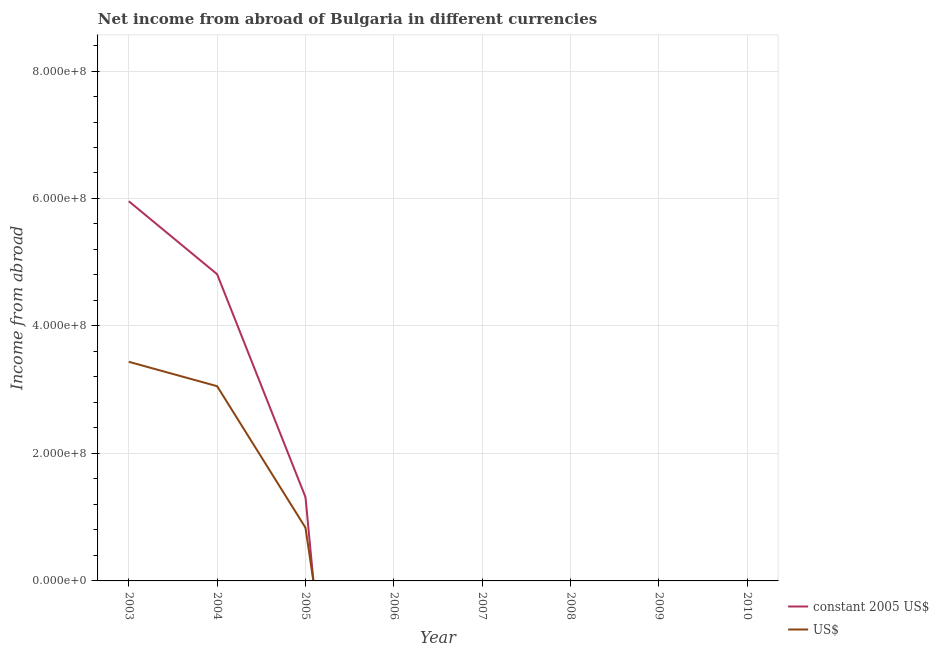Does the line corresponding to income from abroad in constant 2005 us$ intersect with the line corresponding to income from abroad in us$?
Ensure brevity in your answer.  Yes. Is the number of lines equal to the number of legend labels?
Your response must be concise. No. Across all years, what is the maximum income from abroad in constant 2005 us$?
Provide a succinct answer. 5.96e+08. Across all years, what is the minimum income from abroad in constant 2005 us$?
Ensure brevity in your answer.  0. What is the total income from abroad in constant 2005 us$ in the graph?
Make the answer very short. 1.21e+09. What is the difference between the income from abroad in us$ in 2003 and that in 2004?
Give a very brief answer. 3.83e+07. What is the difference between the income from abroad in us$ in 2003 and the income from abroad in constant 2005 us$ in 2008?
Make the answer very short. 3.44e+08. What is the average income from abroad in us$ per year?
Keep it short and to the point. 9.16e+07. In the year 2004, what is the difference between the income from abroad in us$ and income from abroad in constant 2005 us$?
Provide a succinct answer. -1.76e+08. What is the ratio of the income from abroad in us$ in 2003 to that in 2005?
Provide a succinct answer. 4.12. Is the difference between the income from abroad in constant 2005 us$ in 2003 and 2004 greater than the difference between the income from abroad in us$ in 2003 and 2004?
Ensure brevity in your answer.  Yes. What is the difference between the highest and the second highest income from abroad in constant 2005 us$?
Offer a terse response. 1.14e+08. What is the difference between the highest and the lowest income from abroad in us$?
Offer a very short reply. 3.44e+08. Does the income from abroad in us$ monotonically increase over the years?
Give a very brief answer. No. Is the income from abroad in us$ strictly greater than the income from abroad in constant 2005 us$ over the years?
Provide a succinct answer. No. How many lines are there?
Your response must be concise. 2. How many years are there in the graph?
Provide a short and direct response. 8. Where does the legend appear in the graph?
Your answer should be very brief. Bottom right. How many legend labels are there?
Provide a succinct answer. 2. What is the title of the graph?
Give a very brief answer. Net income from abroad of Bulgaria in different currencies. What is the label or title of the Y-axis?
Make the answer very short. Income from abroad. What is the Income from abroad in constant 2005 US$ in 2003?
Your response must be concise. 5.96e+08. What is the Income from abroad in US$ in 2003?
Offer a terse response. 3.44e+08. What is the Income from abroad in constant 2005 US$ in 2004?
Offer a very short reply. 4.81e+08. What is the Income from abroad of US$ in 2004?
Your answer should be compact. 3.06e+08. What is the Income from abroad of constant 2005 US$ in 2005?
Keep it short and to the point. 1.31e+08. What is the Income from abroad of US$ in 2005?
Your response must be concise. 8.35e+07. What is the Income from abroad of constant 2005 US$ in 2006?
Give a very brief answer. 0. What is the Income from abroad in constant 2005 US$ in 2007?
Your response must be concise. 0. What is the Income from abroad of US$ in 2007?
Ensure brevity in your answer.  0. What is the Income from abroad of US$ in 2008?
Offer a very short reply. 0. What is the Income from abroad in constant 2005 US$ in 2009?
Your response must be concise. 0. What is the Income from abroad of constant 2005 US$ in 2010?
Keep it short and to the point. 0. Across all years, what is the maximum Income from abroad in constant 2005 US$?
Provide a short and direct response. 5.96e+08. Across all years, what is the maximum Income from abroad in US$?
Give a very brief answer. 3.44e+08. What is the total Income from abroad of constant 2005 US$ in the graph?
Ensure brevity in your answer.  1.21e+09. What is the total Income from abroad of US$ in the graph?
Your response must be concise. 7.33e+08. What is the difference between the Income from abroad in constant 2005 US$ in 2003 and that in 2004?
Make the answer very short. 1.14e+08. What is the difference between the Income from abroad of US$ in 2003 and that in 2004?
Make the answer very short. 3.83e+07. What is the difference between the Income from abroad in constant 2005 US$ in 2003 and that in 2005?
Provide a succinct answer. 4.64e+08. What is the difference between the Income from abroad of US$ in 2003 and that in 2005?
Make the answer very short. 2.60e+08. What is the difference between the Income from abroad of constant 2005 US$ in 2004 and that in 2005?
Offer a very short reply. 3.50e+08. What is the difference between the Income from abroad in US$ in 2004 and that in 2005?
Ensure brevity in your answer.  2.22e+08. What is the difference between the Income from abroad of constant 2005 US$ in 2003 and the Income from abroad of US$ in 2004?
Ensure brevity in your answer.  2.90e+08. What is the difference between the Income from abroad in constant 2005 US$ in 2003 and the Income from abroad in US$ in 2005?
Your answer should be compact. 5.12e+08. What is the difference between the Income from abroad in constant 2005 US$ in 2004 and the Income from abroad in US$ in 2005?
Make the answer very short. 3.98e+08. What is the average Income from abroad in constant 2005 US$ per year?
Keep it short and to the point. 1.51e+08. What is the average Income from abroad of US$ per year?
Offer a terse response. 9.16e+07. In the year 2003, what is the difference between the Income from abroad of constant 2005 US$ and Income from abroad of US$?
Make the answer very short. 2.52e+08. In the year 2004, what is the difference between the Income from abroad in constant 2005 US$ and Income from abroad in US$?
Provide a short and direct response. 1.76e+08. In the year 2005, what is the difference between the Income from abroad of constant 2005 US$ and Income from abroad of US$?
Your answer should be very brief. 4.79e+07. What is the ratio of the Income from abroad in constant 2005 US$ in 2003 to that in 2004?
Offer a terse response. 1.24. What is the ratio of the Income from abroad of US$ in 2003 to that in 2004?
Make the answer very short. 1.13. What is the ratio of the Income from abroad of constant 2005 US$ in 2003 to that in 2005?
Provide a succinct answer. 4.53. What is the ratio of the Income from abroad of US$ in 2003 to that in 2005?
Provide a succinct answer. 4.12. What is the ratio of the Income from abroad of constant 2005 US$ in 2004 to that in 2005?
Make the answer very short. 3.66. What is the ratio of the Income from abroad in US$ in 2004 to that in 2005?
Give a very brief answer. 3.66. What is the difference between the highest and the second highest Income from abroad of constant 2005 US$?
Give a very brief answer. 1.14e+08. What is the difference between the highest and the second highest Income from abroad of US$?
Ensure brevity in your answer.  3.83e+07. What is the difference between the highest and the lowest Income from abroad in constant 2005 US$?
Your answer should be very brief. 5.96e+08. What is the difference between the highest and the lowest Income from abroad of US$?
Ensure brevity in your answer.  3.44e+08. 